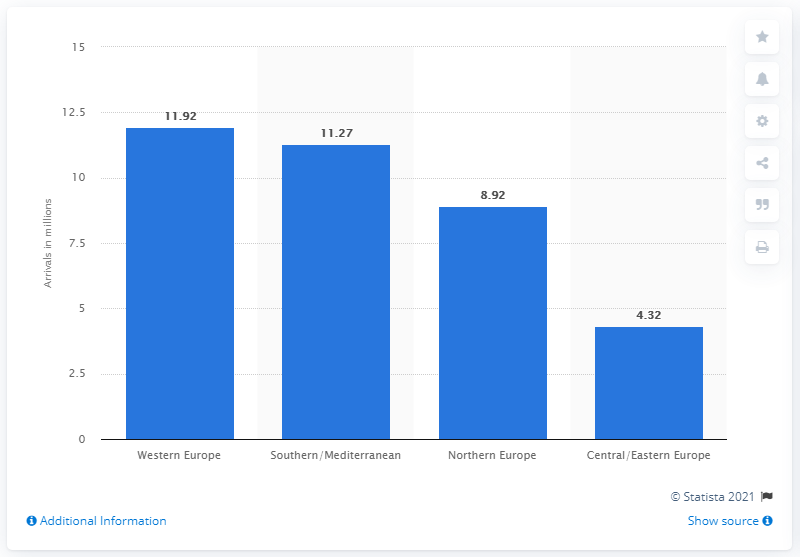Draw attention to some important aspects in this diagram. In 2019, a total of 11,270 tourists from the United States visited Southern/Mediterranean Europe. In 2019, the region that was visited most frequently by U.S. tourists was Western Europe. In 2019, Western Europe recorded a total of 11,920 outbound trips from the United States. 